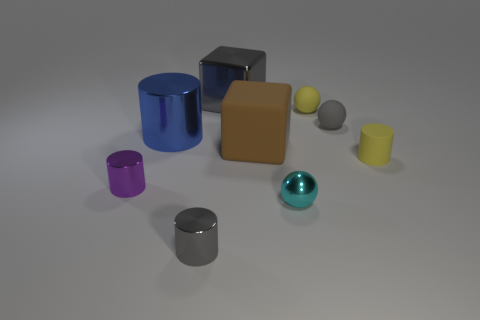How many other objects are there of the same size as the yellow sphere? It's challenging to definitively determine size relations from this perspective, as visual depth can distort perception without further context or measurement tools. However, based on the image and assuming a uniform distance, it appears there are no other objects exactly the same size as the yellow sphere. 